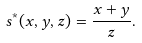Convert formula to latex. <formula><loc_0><loc_0><loc_500><loc_500>s ^ { \ast } ( x , y , z ) = \frac { x + y } { z } .</formula> 